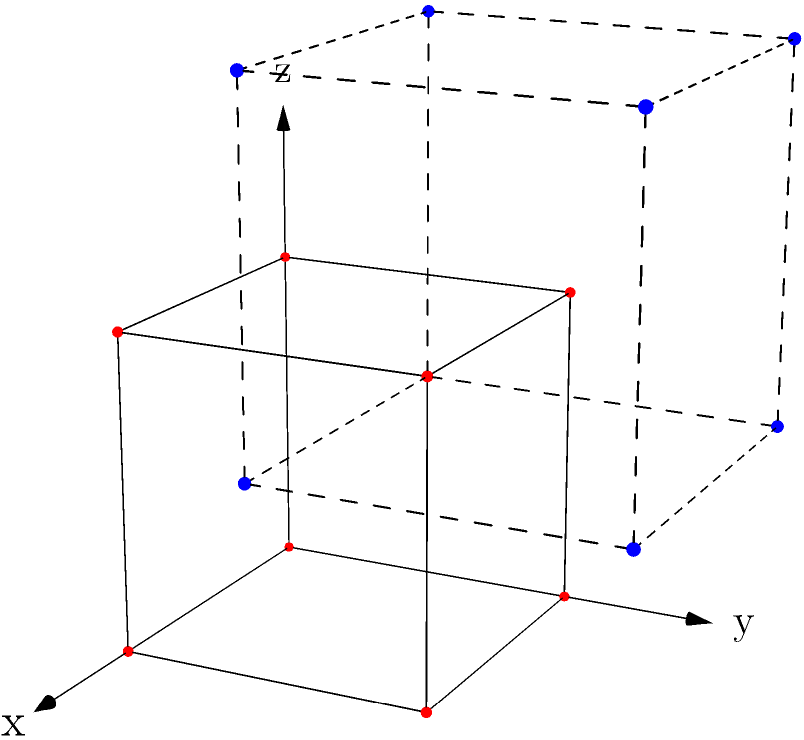In a 3D coordinate system, a unit cube is translated by the vector $\vec{v} = (1, 1, 1)$. How does this translation affect the projection of the cube onto the xy-plane? Explain the change in terms of area and shape, and describe how this relates to the concept of invariance in transformations. To understand the effect of the translation on the projection of the cube onto the xy-plane, let's follow these steps:

1) Initial projection:
   - Before translation, the cube's projection on the xy-plane is a square with side length 1 and area 1 square unit.

2) Translation effect:
   - The translation vector $\vec{v} = (1, 1, 1)$ moves the cube 1 unit in each direction (x, y, and z).
   - The z-component of the translation doesn't affect the xy-projection.

3) New projection:
   - After translation, the cube's projection on the xy-plane is still a square with side length 1 and area 1 square unit.
   - The projection has moved 1 unit in the x-direction and 1 unit in the y-direction.

4) Invariance:
   - The shape and size of the projection remain unchanged, demonstrating invariance under translation.
   - Translations preserve distances, angles, and areas, which is why the projection's shape and size don't change.

5) Educational relevance:
   - This problem illustrates the concept of invariance in transformational geometry.
   - It demonstrates how 3D transformations can be analyzed through 2D projections, linking different areas of mathematics.

In summary, the translation affects the position of the cube's projection on the xy-plane but leaves its shape and area invariant, illustrating a fundamental property of translational transformations.
Answer: The projection's position changes, but its shape and area remain invariant. 